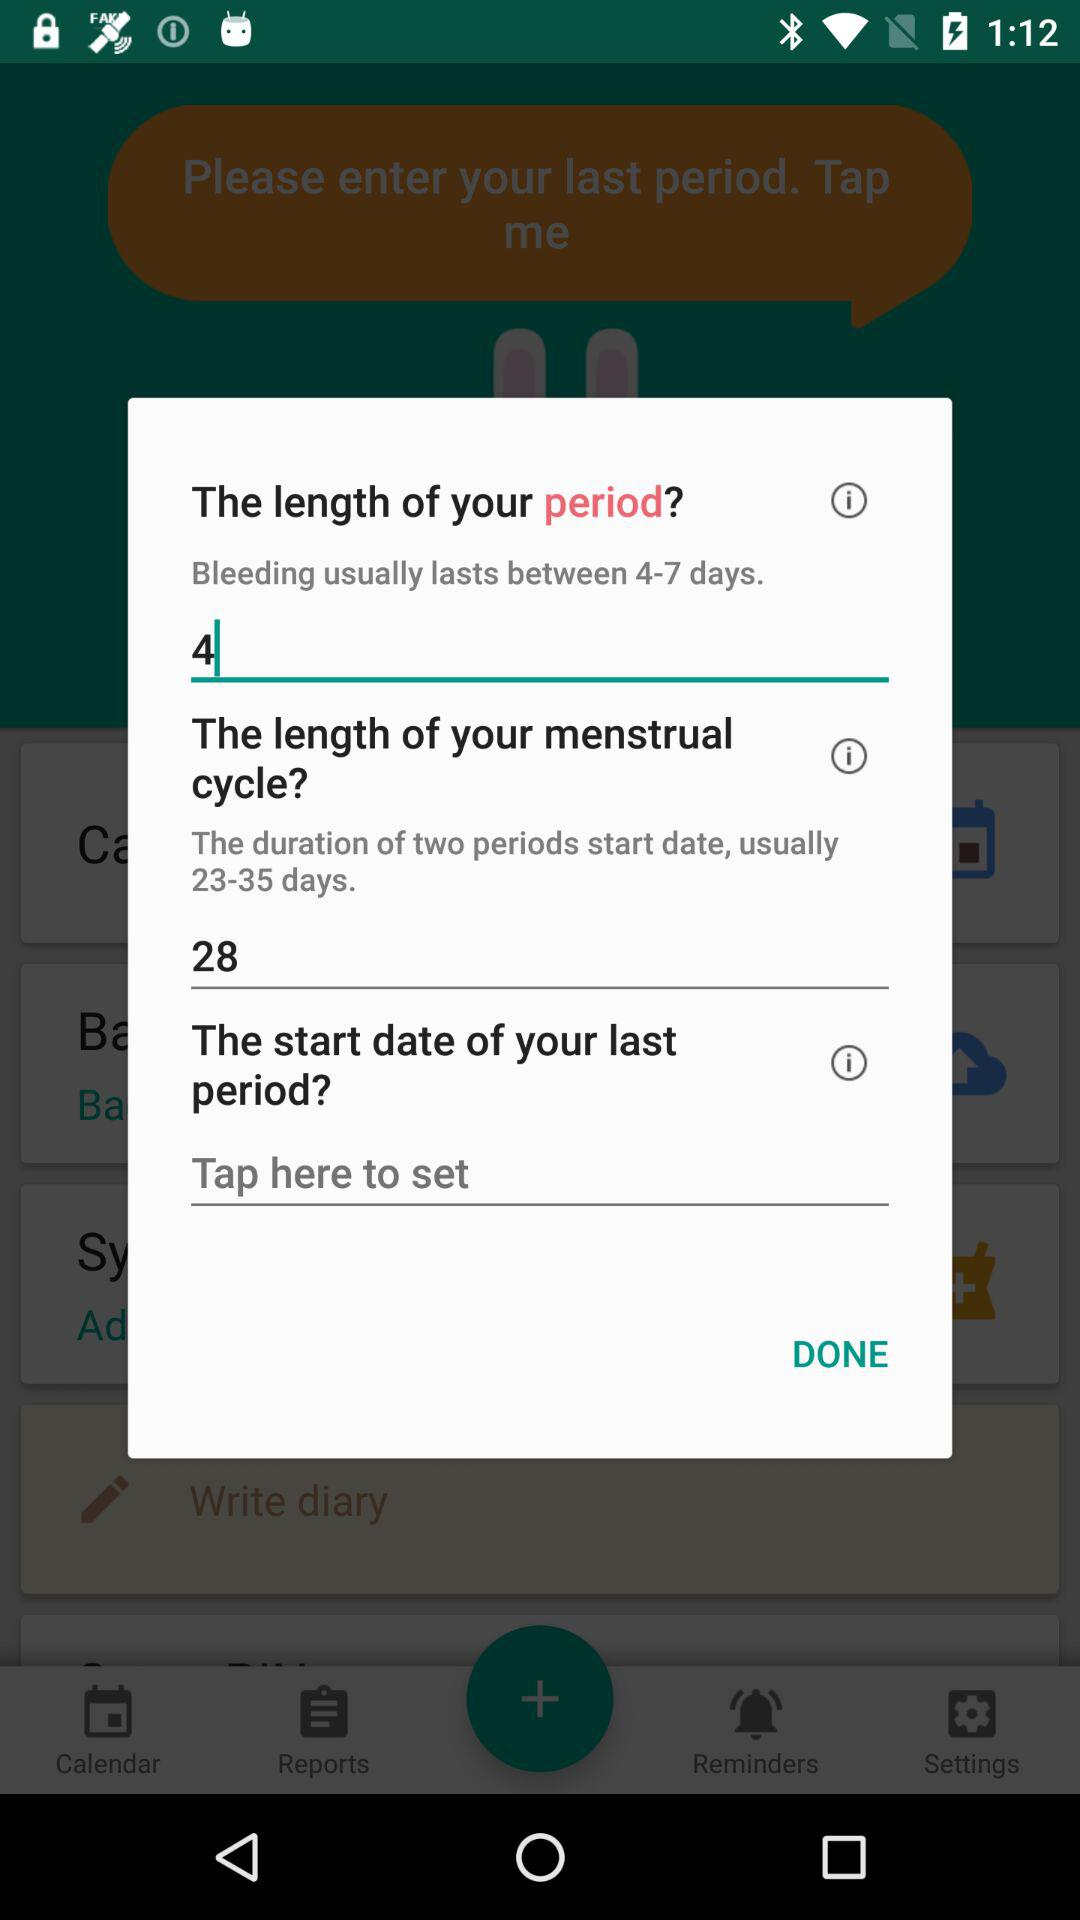What is the length of your period? The length of the period is 4 days. 